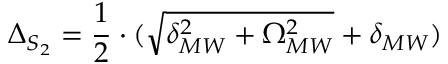<formula> <loc_0><loc_0><loc_500><loc_500>\Delta _ { S _ { 2 } } = \frac { 1 } { 2 } \cdot ( \sqrt { \delta _ { M W } ^ { 2 } + \Omega _ { M W } ^ { 2 } } + \delta _ { M W } )</formula> 